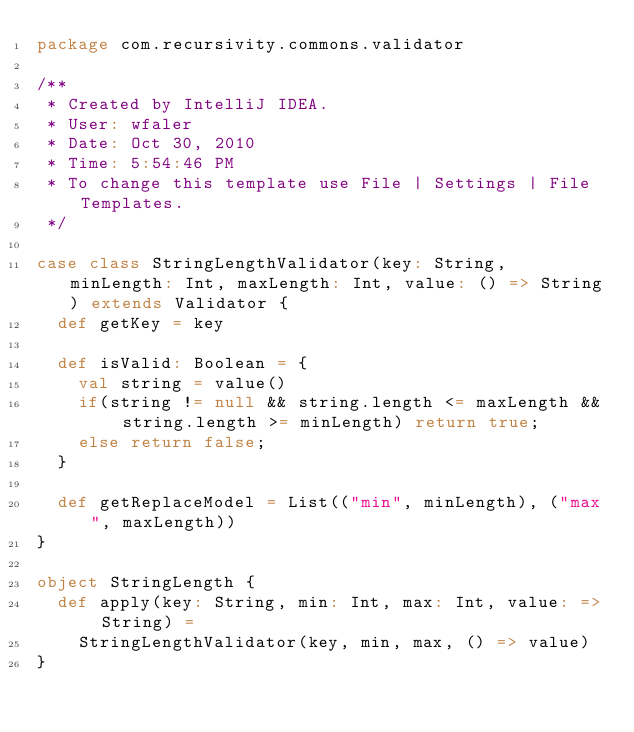Convert code to text. <code><loc_0><loc_0><loc_500><loc_500><_Scala_>package com.recursivity.commons.validator

/**
 * Created by IntelliJ IDEA.
 * User: wfaler
 * Date: Oct 30, 2010
 * Time: 5:54:46 PM
 * To change this template use File | Settings | File Templates.
 */

case class StringLengthValidator(key: String, minLength: Int, maxLength: Int, value: () => String) extends Validator {
  def getKey = key

  def isValid: Boolean = {
    val string = value()
    if(string != null && string.length <= maxLength && string.length >= minLength) return true;
    else return false;
  }

  def getReplaceModel = List(("min", minLength), ("max", maxLength))
}

object StringLength {
  def apply(key: String, min: Int, max: Int, value: => String) =
    StringLengthValidator(key, min, max, () => value)
}
</code> 